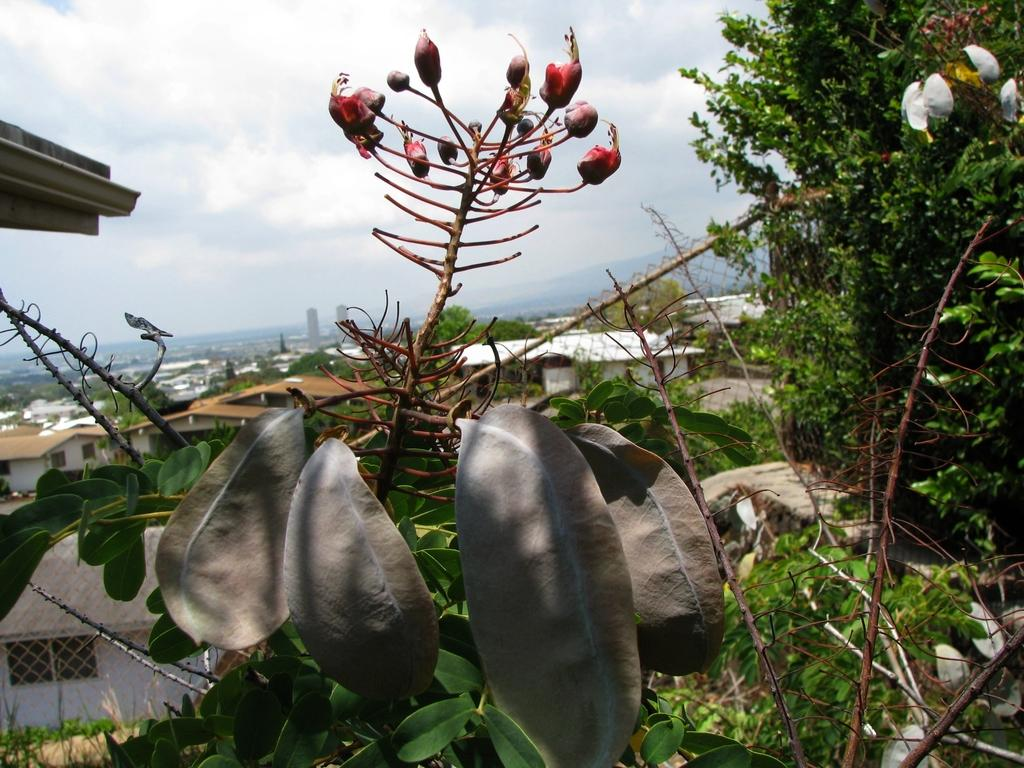What type of fencing is present in the image? There is a net fencing in the image. What kind of plants can be seen in the image? There are plants with flowers in the image. What other natural elements are visible in the image? There are trees in the image. What man-made structures can be seen in the image? There are buildings in the image. What is visible in the sky in the image? There are clouds visible in the sky. Can you see the band performing in the image? There is no band present in the image. What type of plastic objects can be seen in the image? There is no plastic object present in the image. 